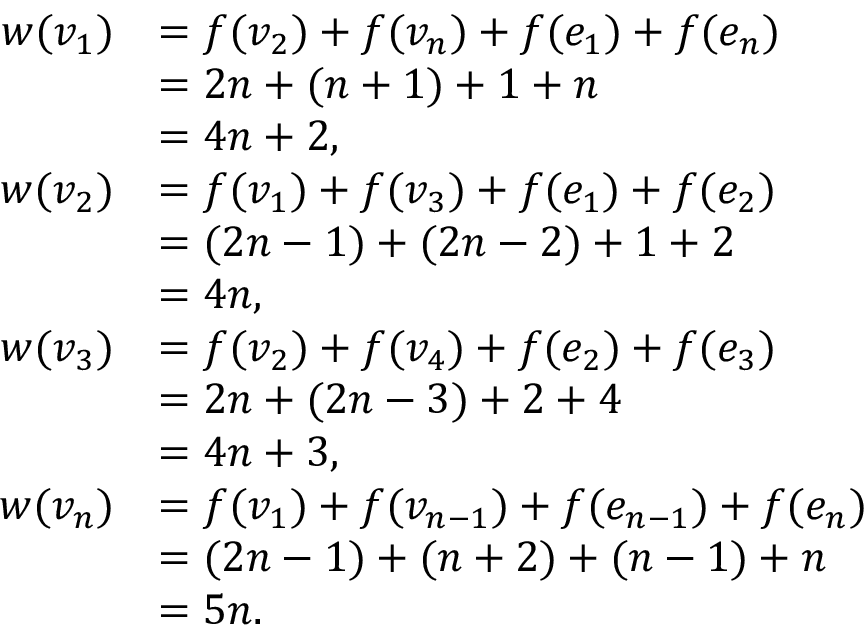Convert formula to latex. <formula><loc_0><loc_0><loc_500><loc_500>\begin{array} { r l } { w ( v _ { 1 } ) } & { = f ( v _ { 2 } ) + f ( v _ { n } ) + f ( e _ { 1 } ) + f ( e _ { n } ) } \\ & { = 2 n + ( n + 1 ) + 1 + n } \\ & { = 4 n + 2 , } \\ { w ( v _ { 2 } ) } & { = f ( v _ { 1 } ) + f ( v _ { 3 } ) + f ( e _ { 1 } ) + f ( e _ { 2 } ) } \\ & { = ( 2 n - 1 ) + ( 2 n - 2 ) + 1 + 2 } \\ & { = 4 n , } \\ { w ( v _ { 3 } ) } & { = f ( v _ { 2 } ) + f ( v _ { 4 } ) + f ( e _ { 2 } ) + f ( e _ { 3 } ) } \\ & { = 2 n + ( 2 n - 3 ) + 2 + 4 } \\ & { = 4 n + 3 , } \\ { w ( v _ { n } ) } & { = f ( v _ { 1 } ) + f ( v _ { n - 1 } ) + f ( e _ { n - 1 } ) + f ( e _ { n } ) } \\ & { = ( 2 n - 1 ) + ( n + 2 ) + ( n - 1 ) + n } \\ & { = 5 n . } \end{array}</formula> 